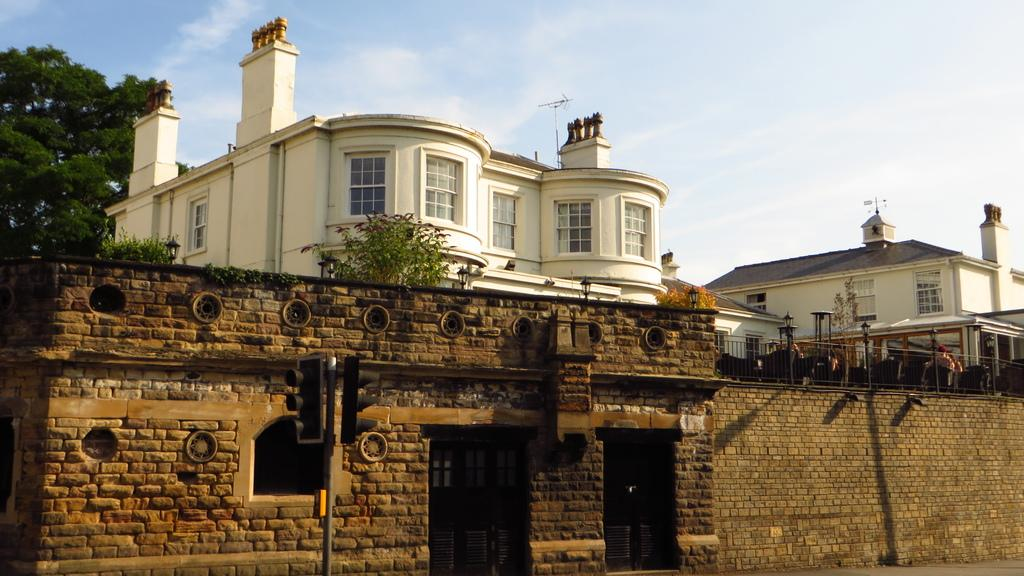What type of structures can be seen in the image? There are buildings in the image. What natural elements are present in the image? There are trees and plants in the image. What type of man-made objects can be seen in the image? There are light poles, railing, and signal lights in the image. Are there any living beings in the image? Yes, there are people in the image. What is the weather like in the image? The sky is cloudy in the image. Can you describe any unspecified objects in the image? There are unspecified objects in the image, but their details are not provided. What type of juice is being served at the attention-grabbing view in the image? There is no mention of juice or a view in the image, and the image does not depict any serving of food or beverages. 